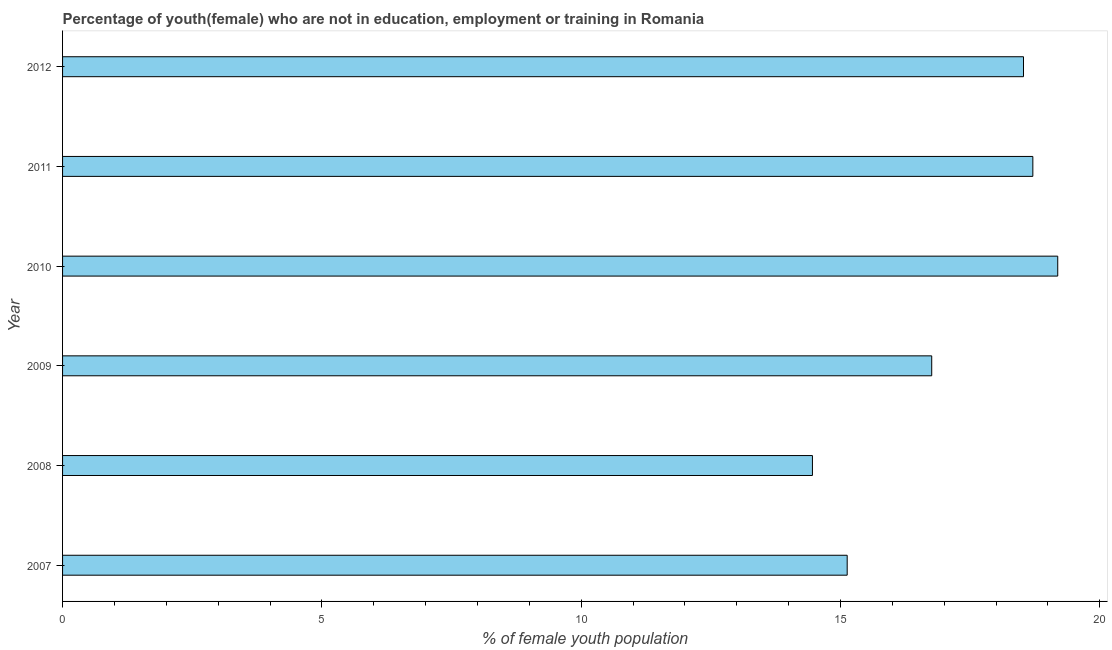Does the graph contain any zero values?
Ensure brevity in your answer.  No. What is the title of the graph?
Your answer should be very brief. Percentage of youth(female) who are not in education, employment or training in Romania. What is the label or title of the X-axis?
Offer a very short reply. % of female youth population. What is the unemployed female youth population in 2011?
Give a very brief answer. 18.71. Across all years, what is the maximum unemployed female youth population?
Your response must be concise. 19.19. Across all years, what is the minimum unemployed female youth population?
Provide a short and direct response. 14.46. In which year was the unemployed female youth population minimum?
Your response must be concise. 2008. What is the sum of the unemployed female youth population?
Ensure brevity in your answer.  102.78. What is the difference between the unemployed female youth population in 2008 and 2009?
Your answer should be compact. -2.3. What is the average unemployed female youth population per year?
Offer a terse response. 17.13. What is the median unemployed female youth population?
Ensure brevity in your answer.  17.65. What is the ratio of the unemployed female youth population in 2008 to that in 2009?
Ensure brevity in your answer.  0.86. Is the unemployed female youth population in 2010 less than that in 2011?
Offer a very short reply. No. What is the difference between the highest and the second highest unemployed female youth population?
Offer a terse response. 0.48. What is the difference between the highest and the lowest unemployed female youth population?
Your answer should be very brief. 4.73. Are all the bars in the graph horizontal?
Your answer should be compact. Yes. What is the % of female youth population in 2007?
Your response must be concise. 15.13. What is the % of female youth population of 2008?
Make the answer very short. 14.46. What is the % of female youth population in 2009?
Offer a very short reply. 16.76. What is the % of female youth population in 2010?
Offer a terse response. 19.19. What is the % of female youth population of 2011?
Your response must be concise. 18.71. What is the % of female youth population of 2012?
Your answer should be very brief. 18.53. What is the difference between the % of female youth population in 2007 and 2008?
Your answer should be compact. 0.67. What is the difference between the % of female youth population in 2007 and 2009?
Keep it short and to the point. -1.63. What is the difference between the % of female youth population in 2007 and 2010?
Give a very brief answer. -4.06. What is the difference between the % of female youth population in 2007 and 2011?
Offer a terse response. -3.58. What is the difference between the % of female youth population in 2008 and 2009?
Provide a short and direct response. -2.3. What is the difference between the % of female youth population in 2008 and 2010?
Keep it short and to the point. -4.73. What is the difference between the % of female youth population in 2008 and 2011?
Provide a succinct answer. -4.25. What is the difference between the % of female youth population in 2008 and 2012?
Offer a terse response. -4.07. What is the difference between the % of female youth population in 2009 and 2010?
Your answer should be compact. -2.43. What is the difference between the % of female youth population in 2009 and 2011?
Keep it short and to the point. -1.95. What is the difference between the % of female youth population in 2009 and 2012?
Offer a terse response. -1.77. What is the difference between the % of female youth population in 2010 and 2011?
Your answer should be very brief. 0.48. What is the difference between the % of female youth population in 2010 and 2012?
Offer a terse response. 0.66. What is the difference between the % of female youth population in 2011 and 2012?
Ensure brevity in your answer.  0.18. What is the ratio of the % of female youth population in 2007 to that in 2008?
Ensure brevity in your answer.  1.05. What is the ratio of the % of female youth population in 2007 to that in 2009?
Offer a very short reply. 0.9. What is the ratio of the % of female youth population in 2007 to that in 2010?
Your answer should be compact. 0.79. What is the ratio of the % of female youth population in 2007 to that in 2011?
Give a very brief answer. 0.81. What is the ratio of the % of female youth population in 2007 to that in 2012?
Keep it short and to the point. 0.82. What is the ratio of the % of female youth population in 2008 to that in 2009?
Provide a succinct answer. 0.86. What is the ratio of the % of female youth population in 2008 to that in 2010?
Your response must be concise. 0.75. What is the ratio of the % of female youth population in 2008 to that in 2011?
Your answer should be compact. 0.77. What is the ratio of the % of female youth population in 2008 to that in 2012?
Your response must be concise. 0.78. What is the ratio of the % of female youth population in 2009 to that in 2010?
Your answer should be very brief. 0.87. What is the ratio of the % of female youth population in 2009 to that in 2011?
Keep it short and to the point. 0.9. What is the ratio of the % of female youth population in 2009 to that in 2012?
Ensure brevity in your answer.  0.9. What is the ratio of the % of female youth population in 2010 to that in 2012?
Ensure brevity in your answer.  1.04. What is the ratio of the % of female youth population in 2011 to that in 2012?
Provide a short and direct response. 1.01. 